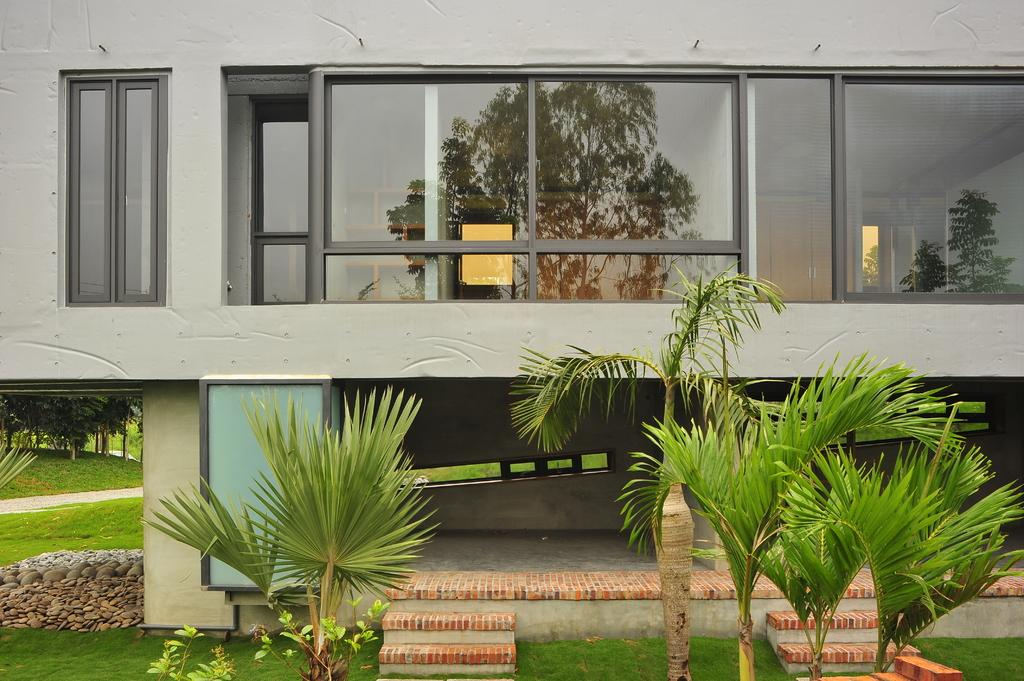What type of vegetation is located at the bottom of the image? There are plants at the bottom of the image. What can be seen in the background of the image? There is a building in the background of the image. What type of terrain is visible in the image? There is a grassy land visible in the image. Where are the trees located in the image? Trees are present on the left side of the image. What type of parcel is being delivered to the building in the image? There is no parcel visible in the image, and no indication of a delivery being made. What is the source of shame in the image? There is no shame present in the image; it features plants, a building, grassy land, and trees. 